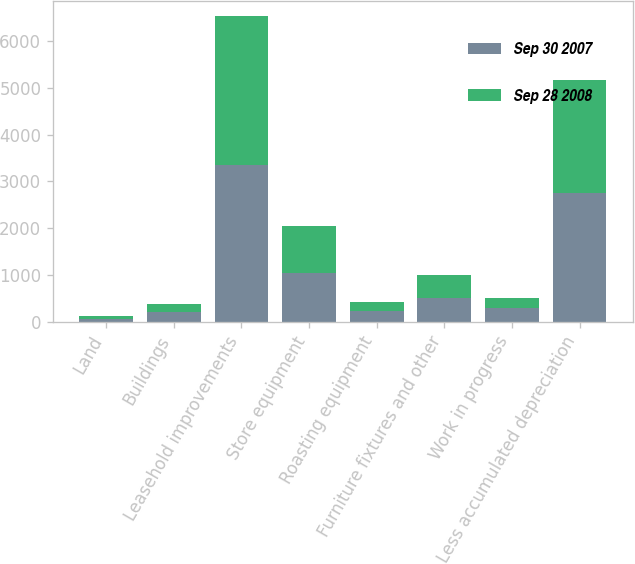Convert chart to OTSL. <chart><loc_0><loc_0><loc_500><loc_500><stacked_bar_chart><ecel><fcel>Land<fcel>Buildings<fcel>Leasehold improvements<fcel>Store equipment<fcel>Roasting equipment<fcel>Furniture fixtures and other<fcel>Work in progress<fcel>Less accumulated depreciation<nl><fcel>Sep 30 2007<fcel>59.1<fcel>217.7<fcel>3363.1<fcel>1045.3<fcel>220.7<fcel>517.8<fcel>293.6<fcel>2760.9<nl><fcel>Sep 28 2008<fcel>56.2<fcel>161.7<fcel>3179.6<fcel>1007<fcel>208.8<fcel>477.9<fcel>215.3<fcel>2416.1<nl></chart> 